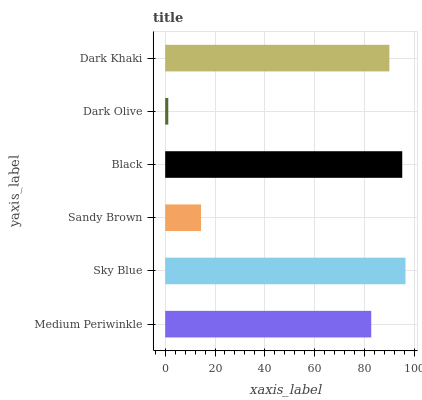Is Dark Olive the minimum?
Answer yes or no. Yes. Is Sky Blue the maximum?
Answer yes or no. Yes. Is Sandy Brown the minimum?
Answer yes or no. No. Is Sandy Brown the maximum?
Answer yes or no. No. Is Sky Blue greater than Sandy Brown?
Answer yes or no. Yes. Is Sandy Brown less than Sky Blue?
Answer yes or no. Yes. Is Sandy Brown greater than Sky Blue?
Answer yes or no. No. Is Sky Blue less than Sandy Brown?
Answer yes or no. No. Is Dark Khaki the high median?
Answer yes or no. Yes. Is Medium Periwinkle the low median?
Answer yes or no. Yes. Is Sky Blue the high median?
Answer yes or no. No. Is Sandy Brown the low median?
Answer yes or no. No. 